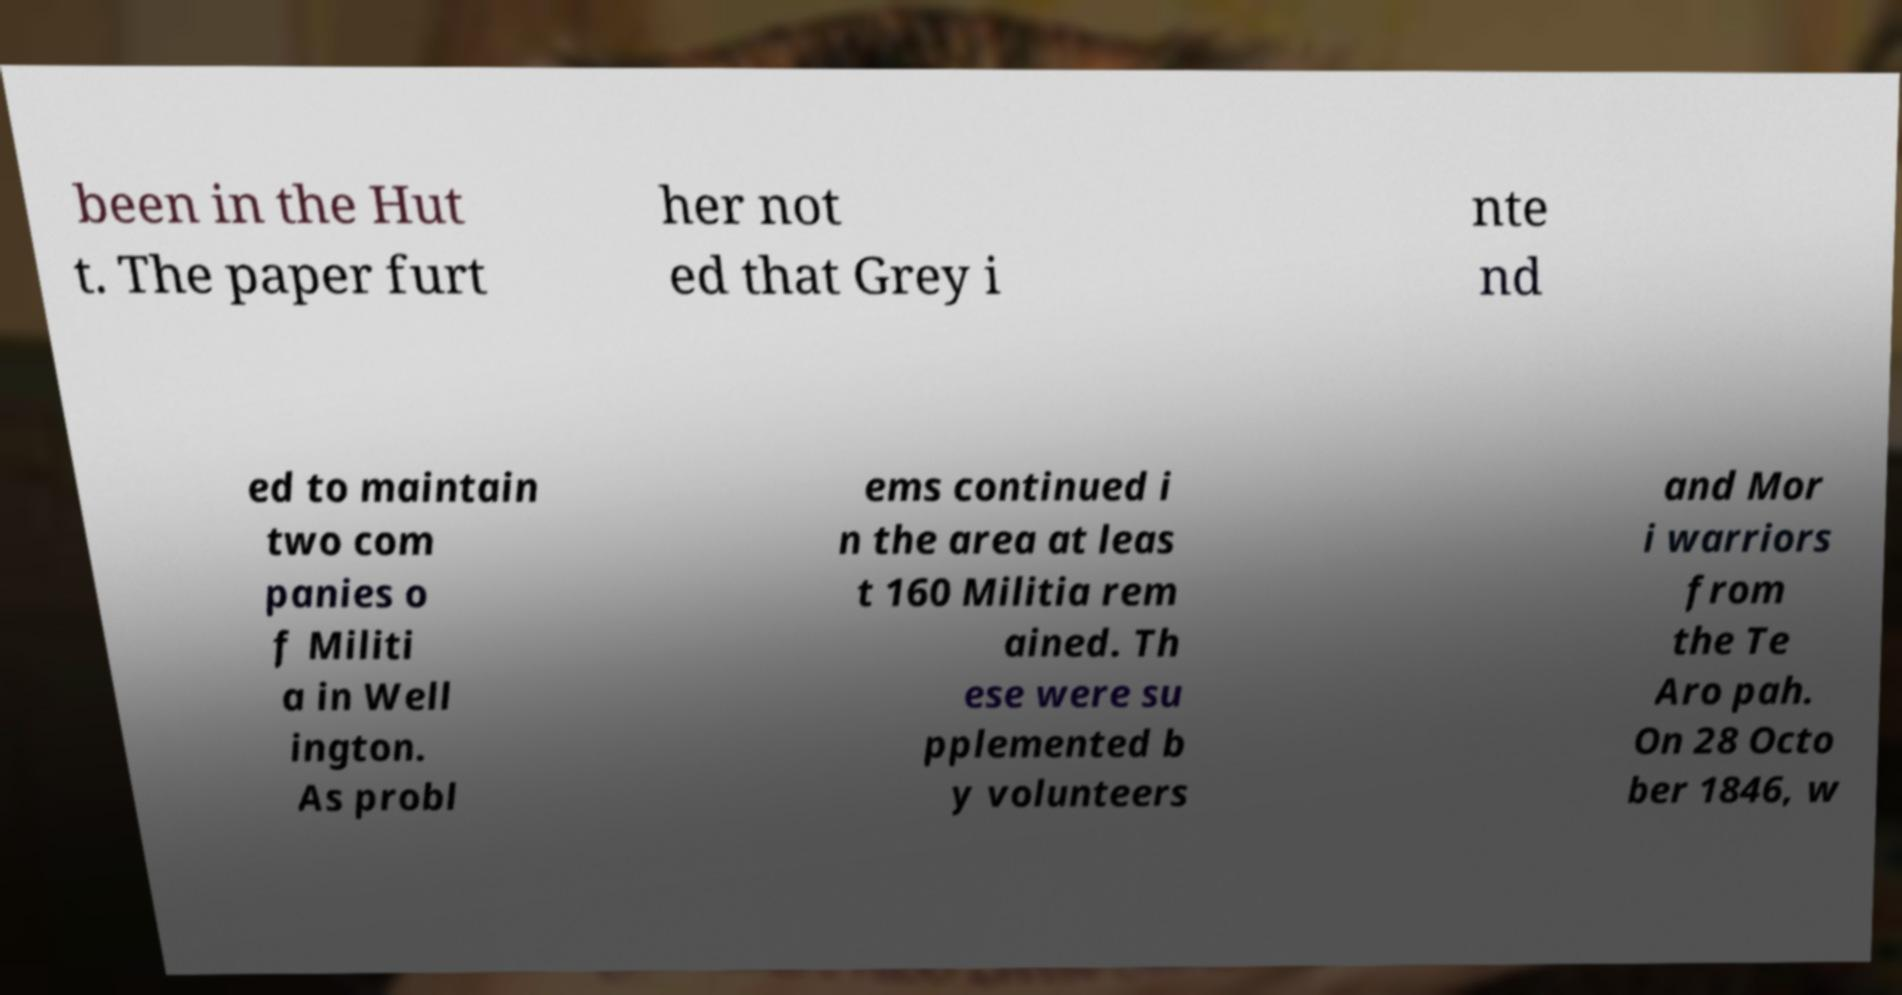Please read and relay the text visible in this image. What does it say? been in the Hut t. The paper furt her not ed that Grey i nte nd ed to maintain two com panies o f Militi a in Well ington. As probl ems continued i n the area at leas t 160 Militia rem ained. Th ese were su pplemented b y volunteers and Mor i warriors from the Te Aro pah. On 28 Octo ber 1846, w 